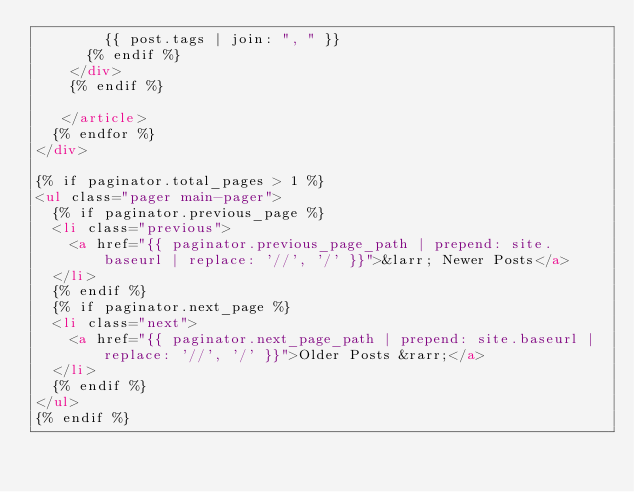<code> <loc_0><loc_0><loc_500><loc_500><_HTML_>        {{ post.tags | join: ", " }}
      {% endif %}
    </div>
    {% endif %}

   </article>
  {% endfor %}
</div>

{% if paginator.total_pages > 1 %}
<ul class="pager main-pager">
  {% if paginator.previous_page %}
  <li class="previous">
    <a href="{{ paginator.previous_page_path | prepend: site.baseurl | replace: '//', '/' }}">&larr; Newer Posts</a>
  </li>
  {% endif %}
  {% if paginator.next_page %}
  <li class="next">
    <a href="{{ paginator.next_page_path | prepend: site.baseurl | replace: '//', '/' }}">Older Posts &rarr;</a>
  </li>
  {% endif %}
</ul>
{% endif %}
</code> 